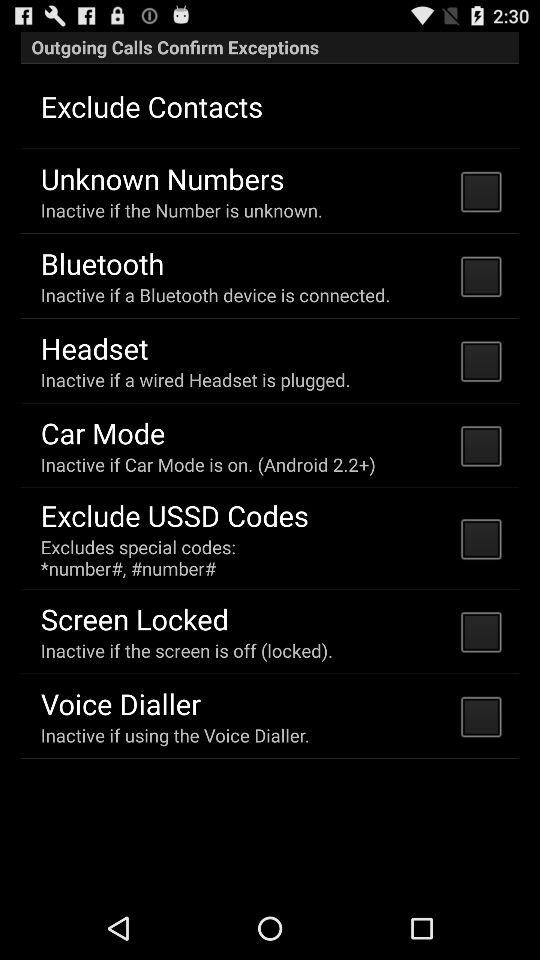What is the status of "Bluetooth"? The status is "off". 